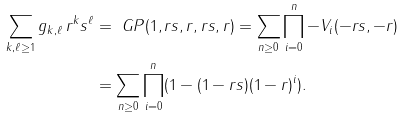<formula> <loc_0><loc_0><loc_500><loc_500>\sum _ { k , \ell \geq 1 } g _ { k , \ell } \, r ^ { k } s ^ { \ell } & = \ G P ( 1 , r s , r , r s , r ) = \sum _ { n \geq 0 } \prod _ { i = 0 } ^ { n } - V _ { i } ( - r s , - r ) \\ & = \sum _ { n \geq 0 } \prod _ { i = 0 } ^ { n } ( 1 - ( 1 - r s ) ( 1 - r ) ^ { i } ) .</formula> 